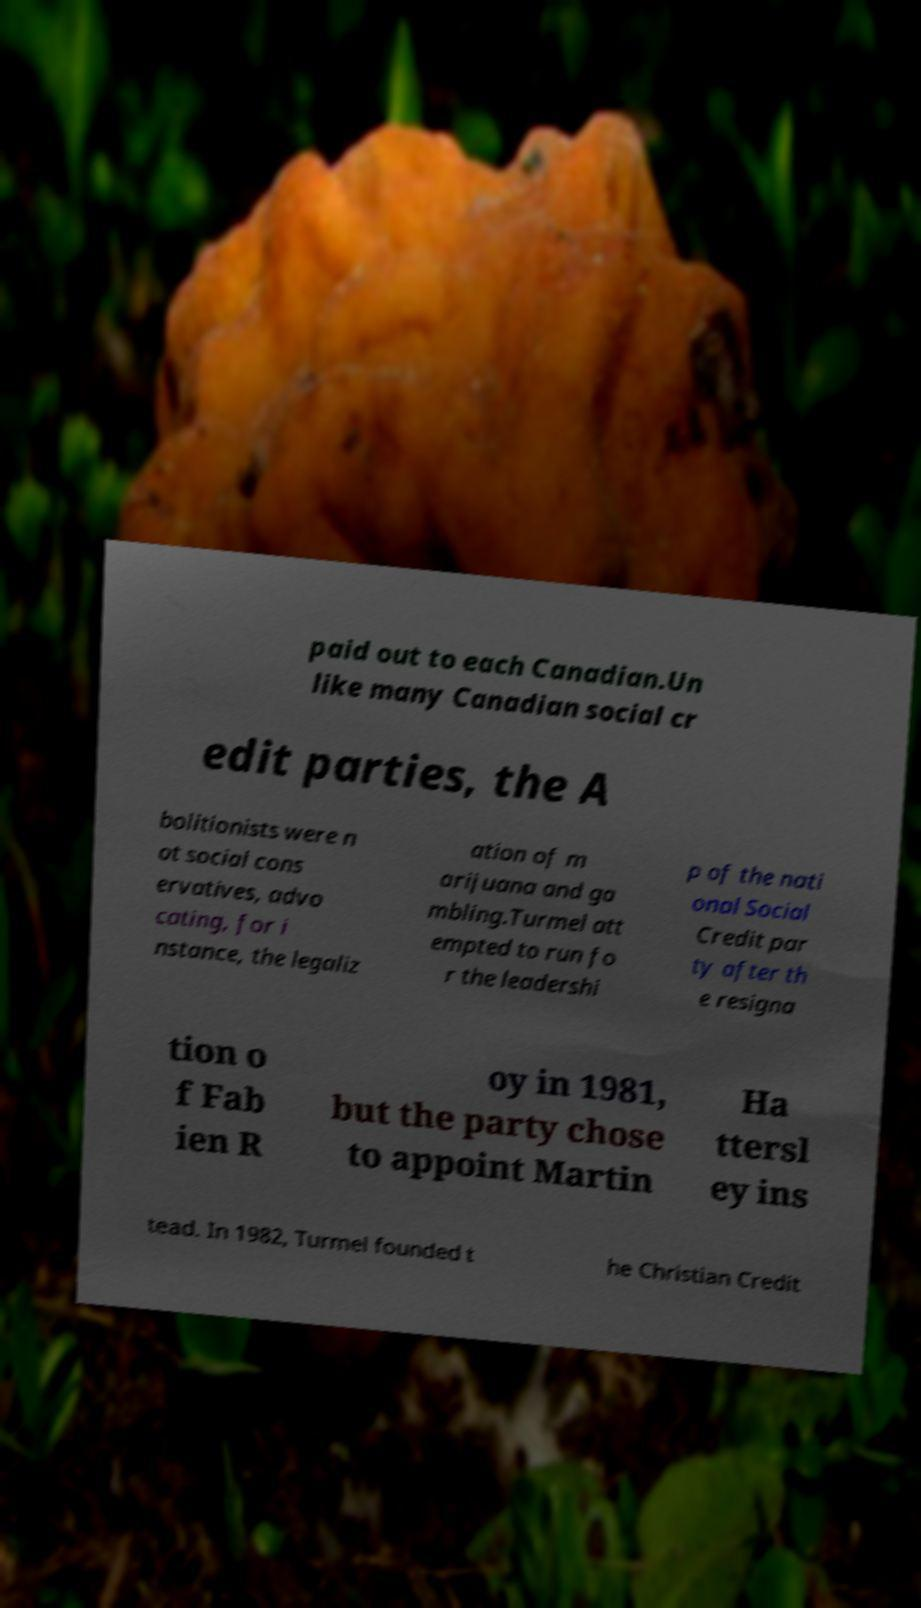Could you assist in decoding the text presented in this image and type it out clearly? paid out to each Canadian.Un like many Canadian social cr edit parties, the A bolitionists were n ot social cons ervatives, advo cating, for i nstance, the legaliz ation of m arijuana and ga mbling.Turmel att empted to run fo r the leadershi p of the nati onal Social Credit par ty after th e resigna tion o f Fab ien R oy in 1981, but the party chose to appoint Martin Ha ttersl ey ins tead. In 1982, Turmel founded t he Christian Credit 